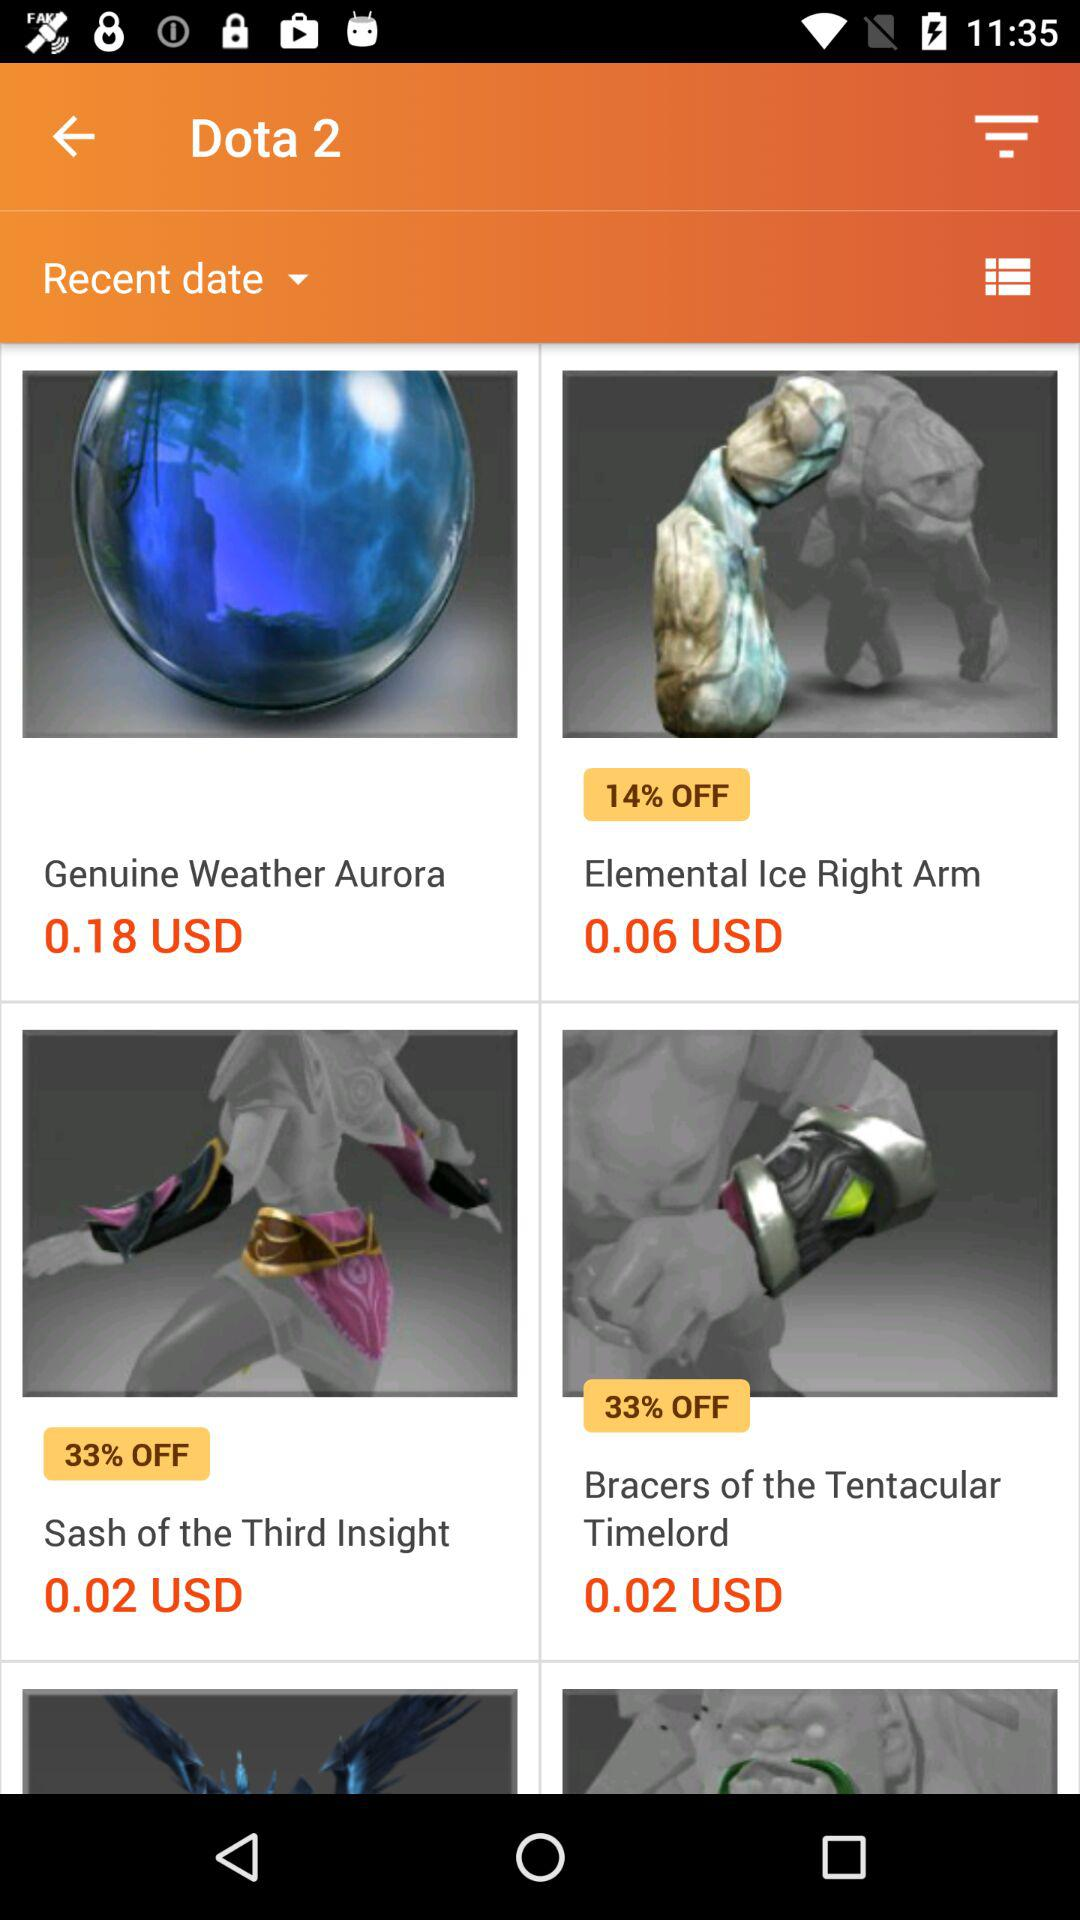What is the currency of price? The currency of price is USD. 